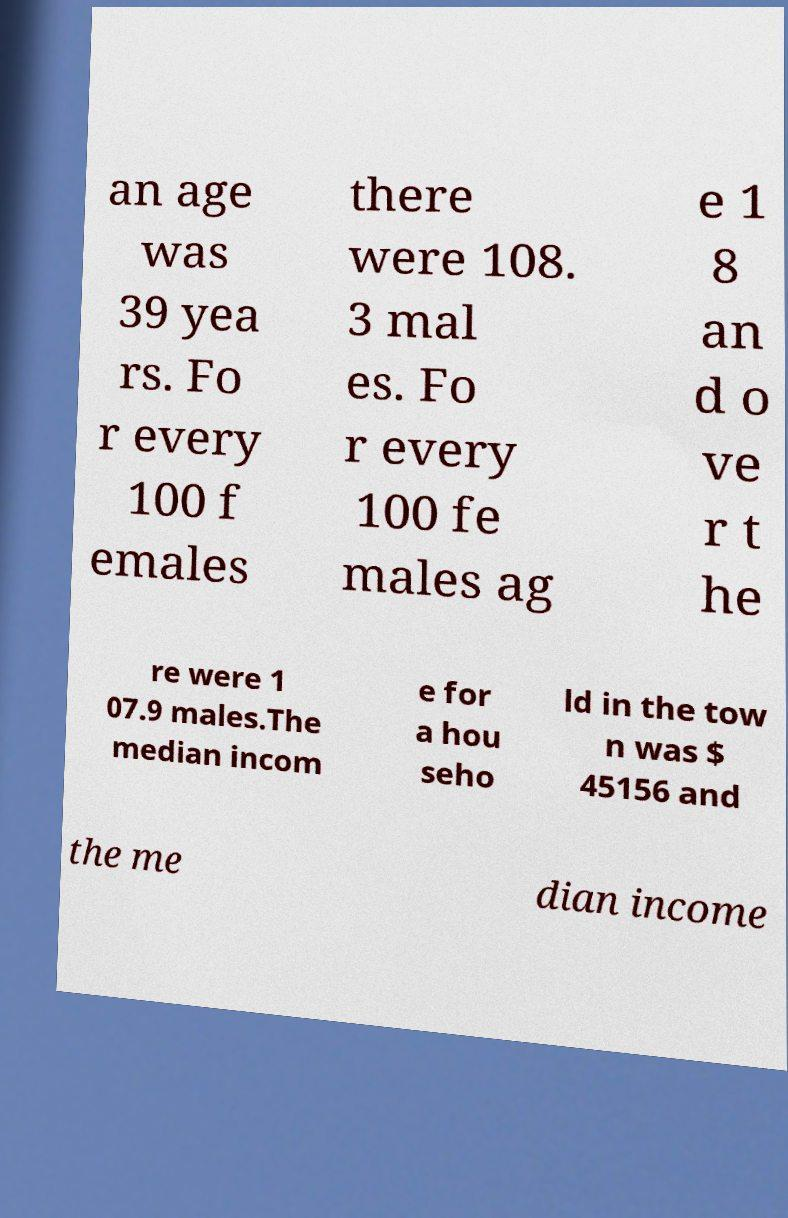Could you extract and type out the text from this image? an age was 39 yea rs. Fo r every 100 f emales there were 108. 3 mal es. Fo r every 100 fe males ag e 1 8 an d o ve r t he re were 1 07.9 males.The median incom e for a hou seho ld in the tow n was $ 45156 and the me dian income 